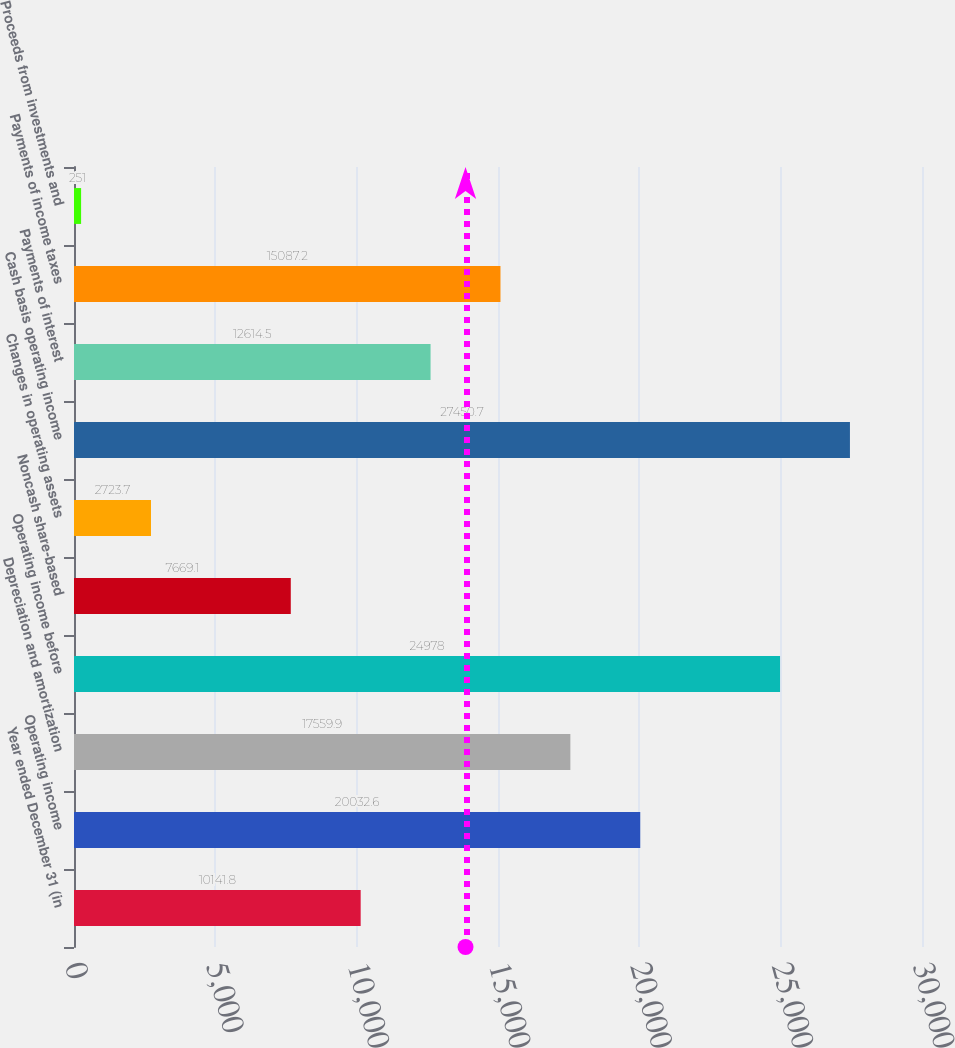Convert chart to OTSL. <chart><loc_0><loc_0><loc_500><loc_500><bar_chart><fcel>Year ended December 31 (in<fcel>Operating income<fcel>Depreciation and amortization<fcel>Operating income before<fcel>Noncash share-based<fcel>Changes in operating assets<fcel>Cash basis operating income<fcel>Payments of interest<fcel>Payments of income taxes<fcel>Proceeds from investments and<nl><fcel>10141.8<fcel>20032.6<fcel>17559.9<fcel>24978<fcel>7669.1<fcel>2723.7<fcel>27450.7<fcel>12614.5<fcel>15087.2<fcel>251<nl></chart> 